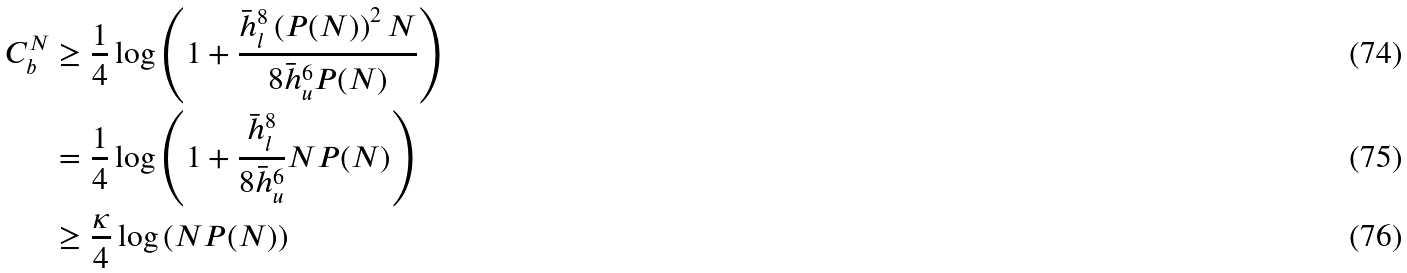Convert formula to latex. <formula><loc_0><loc_0><loc_500><loc_500>C _ { b } ^ { N } & \geq \frac { 1 } { 4 } \log \left ( 1 + \frac { \bar { h } _ { l } ^ { 8 } \left ( P ( N ) \right ) ^ { 2 } N } { 8 \bar { h } _ { u } ^ { 6 } P ( N ) } \right ) \\ & = \frac { 1 } { 4 } \log \left ( 1 + \frac { \bar { h } _ { l } ^ { 8 } } { 8 \bar { h } _ { u } ^ { 6 } } N P ( N ) \right ) \\ & \geq \frac { \kappa } { 4 } \log \left ( N P ( N ) \right )</formula> 